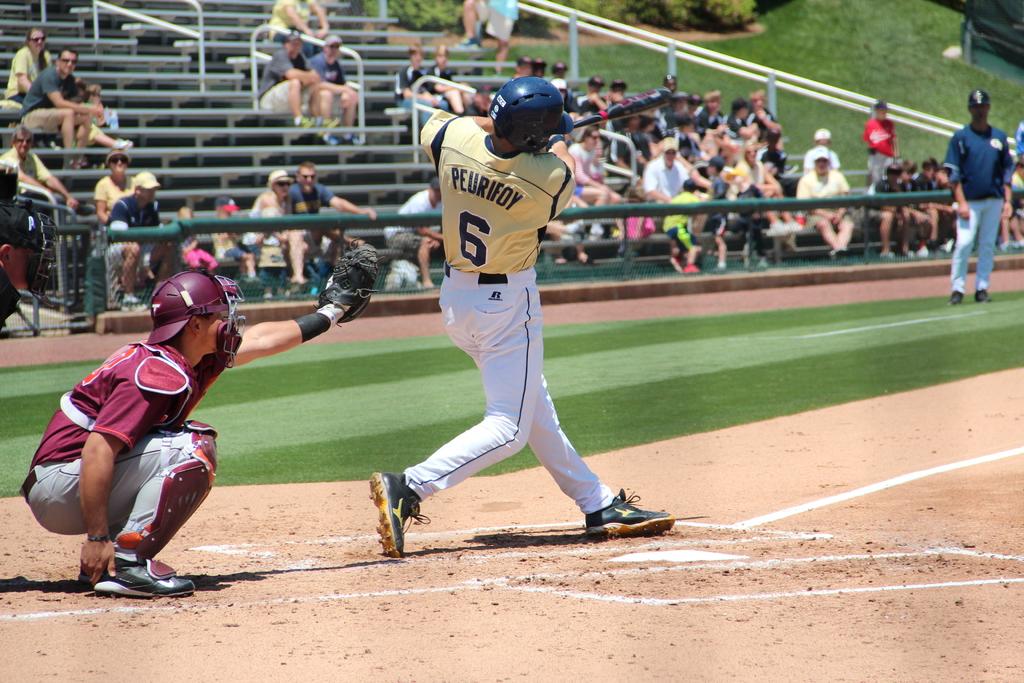What number is at bat?
Provide a succinct answer. 6. 